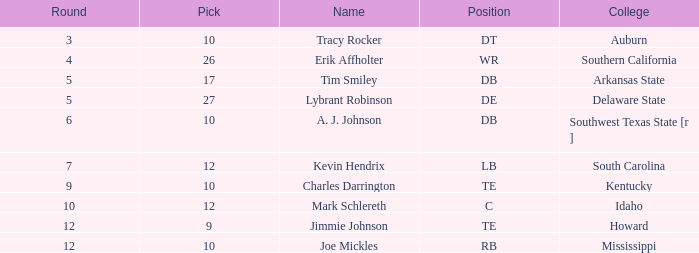What is the average Pick, when Name is "Lybrant Robinson", and when Overall is less than 139? None. 